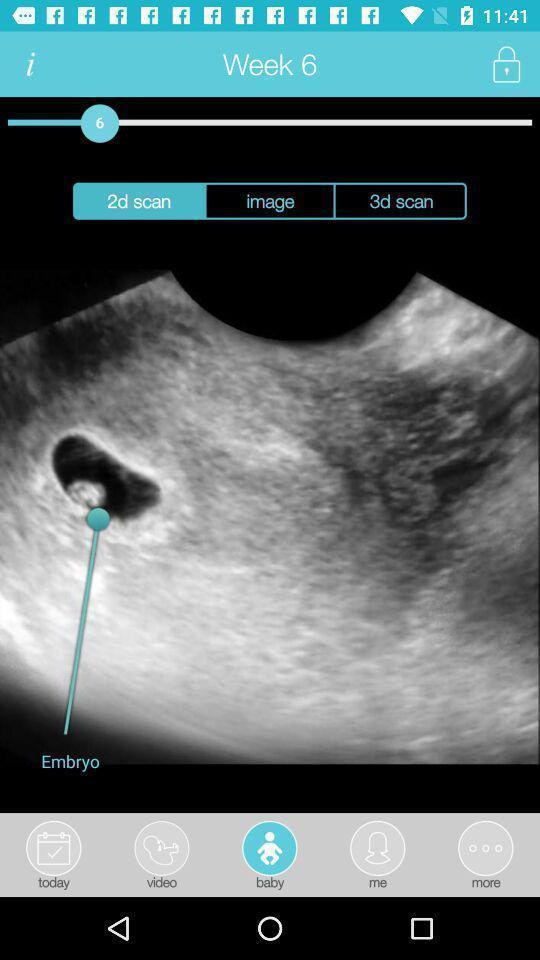Tell me what you see in this picture. Screen showing week 6. 